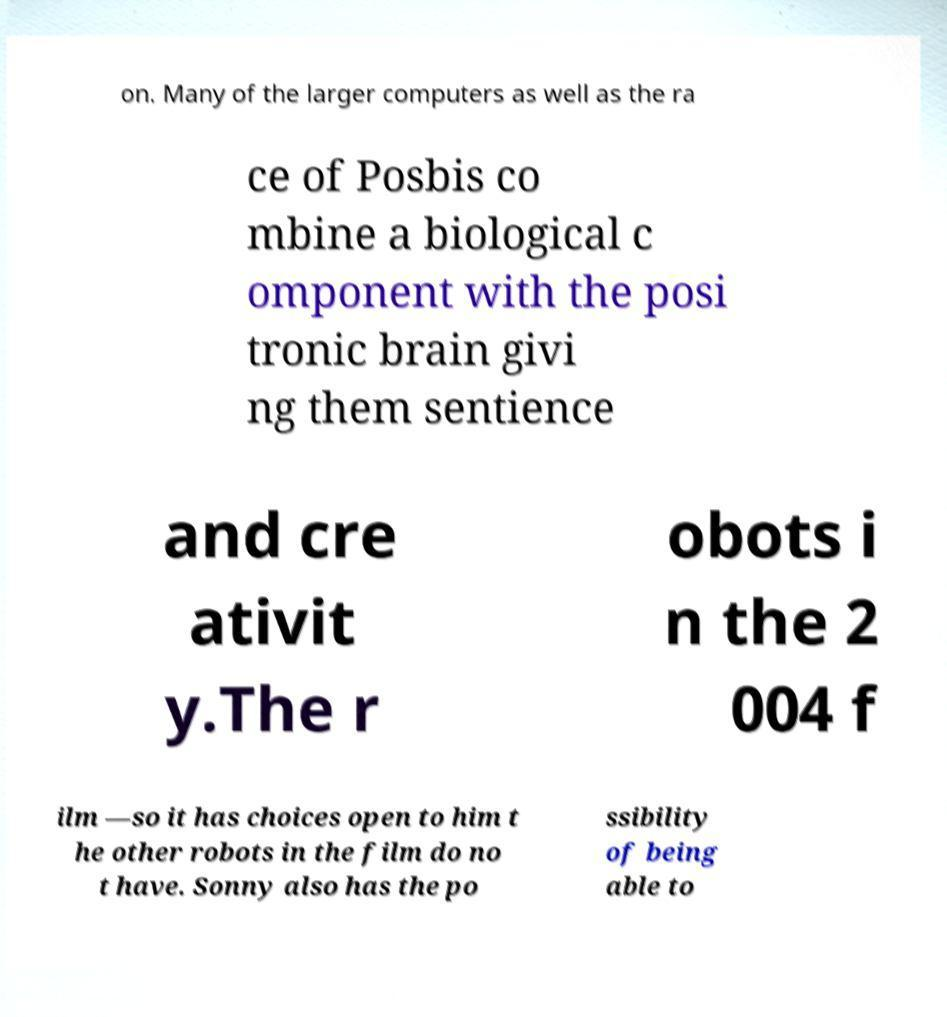I need the written content from this picture converted into text. Can you do that? on. Many of the larger computers as well as the ra ce of Posbis co mbine a biological c omponent with the posi tronic brain givi ng them sentience and cre ativit y.The r obots i n the 2 004 f ilm —so it has choices open to him t he other robots in the film do no t have. Sonny also has the po ssibility of being able to 